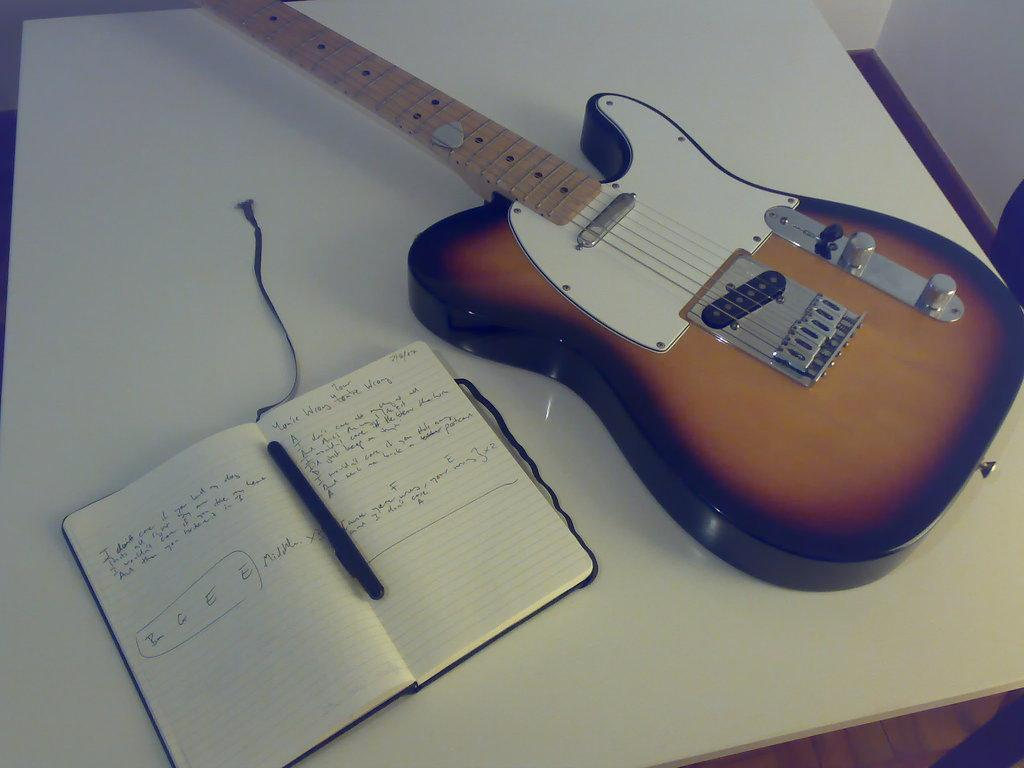What musical instrument is present in the image? There is a guitar in the image. What non-musical item can be seen in the image? There is a book in the image. What writing instrument is visible in the image? There is a pen in the image. Where are all the items located in the image? All items are on a table. What type of step can be seen in the image? There is no step present in the image. What form does the guitar take in the image? The guitar is in its typical form, with a body, neck, and strings. 